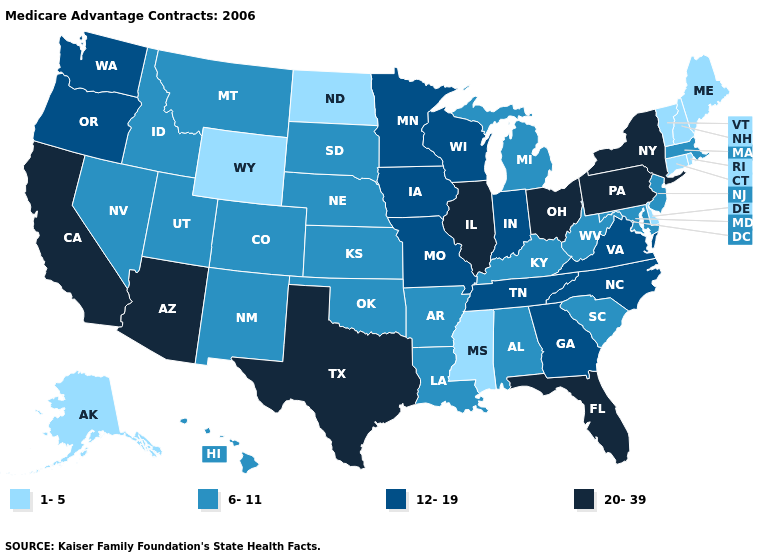What is the value of Delaware?
Short answer required. 1-5. What is the highest value in the USA?
Answer briefly. 20-39. Is the legend a continuous bar?
Be succinct. No. Name the states that have a value in the range 12-19?
Answer briefly. Georgia, Iowa, Indiana, Minnesota, Missouri, North Carolina, Oregon, Tennessee, Virginia, Washington, Wisconsin. Which states have the lowest value in the USA?
Concise answer only. Alaska, Connecticut, Delaware, Maine, Mississippi, North Dakota, New Hampshire, Rhode Island, Vermont, Wyoming. Does Georgia have the same value as Indiana?
Give a very brief answer. Yes. Does Maryland have the same value as Rhode Island?
Short answer required. No. Is the legend a continuous bar?
Write a very short answer. No. How many symbols are there in the legend?
Write a very short answer. 4. Among the states that border North Dakota , does Minnesota have the highest value?
Give a very brief answer. Yes. What is the highest value in the USA?
Give a very brief answer. 20-39. What is the value of Tennessee?
Write a very short answer. 12-19. What is the value of South Dakota?
Answer briefly. 6-11. Name the states that have a value in the range 1-5?
Answer briefly. Alaska, Connecticut, Delaware, Maine, Mississippi, North Dakota, New Hampshire, Rhode Island, Vermont, Wyoming. Which states have the highest value in the USA?
Keep it brief. Arizona, California, Florida, Illinois, New York, Ohio, Pennsylvania, Texas. 